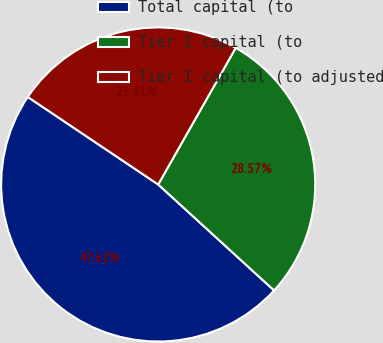Convert chart to OTSL. <chart><loc_0><loc_0><loc_500><loc_500><pie_chart><fcel>Total capital (to<fcel>Tier I capital (to<fcel>Tier I capital (to adjusted<nl><fcel>47.62%<fcel>28.57%<fcel>23.81%<nl></chart> 